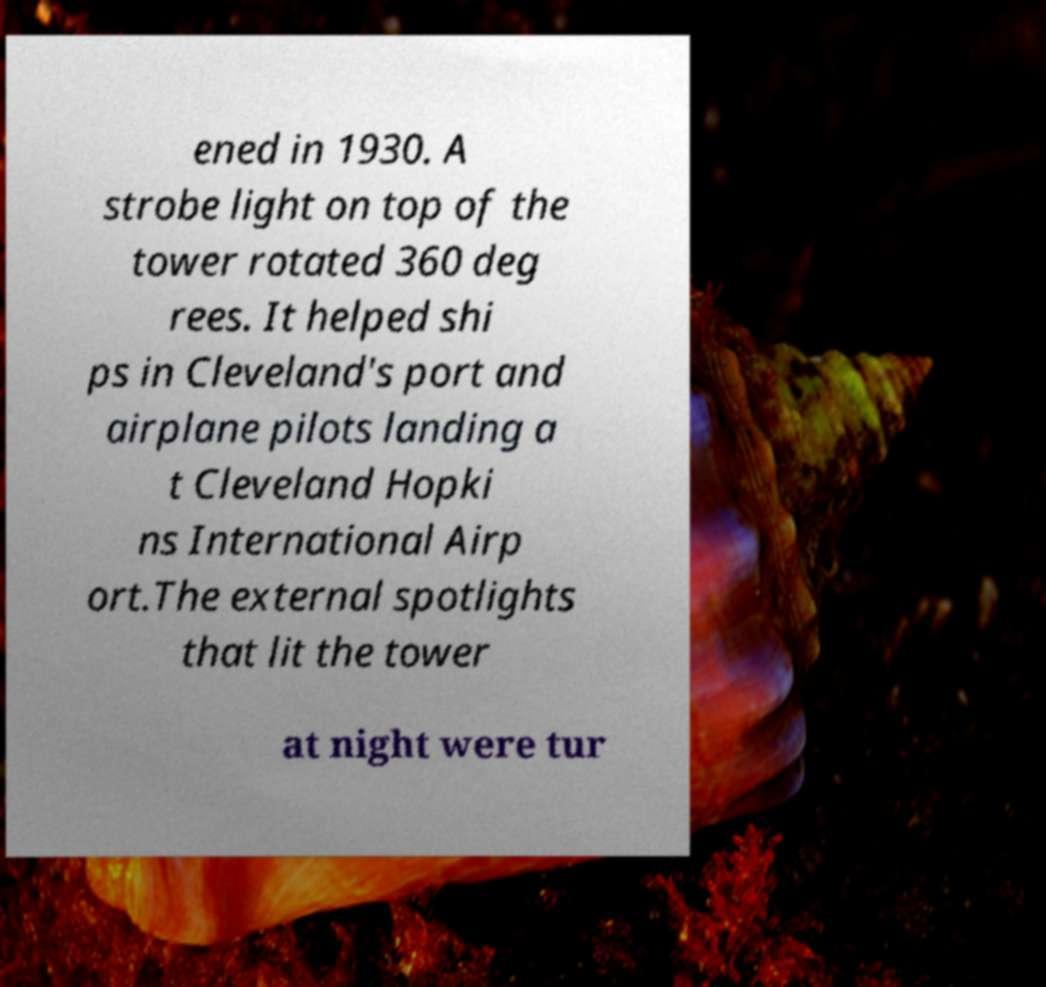I need the written content from this picture converted into text. Can you do that? ened in 1930. A strobe light on top of the tower rotated 360 deg rees. It helped shi ps in Cleveland's port and airplane pilots landing a t Cleveland Hopki ns International Airp ort.The external spotlights that lit the tower at night were tur 